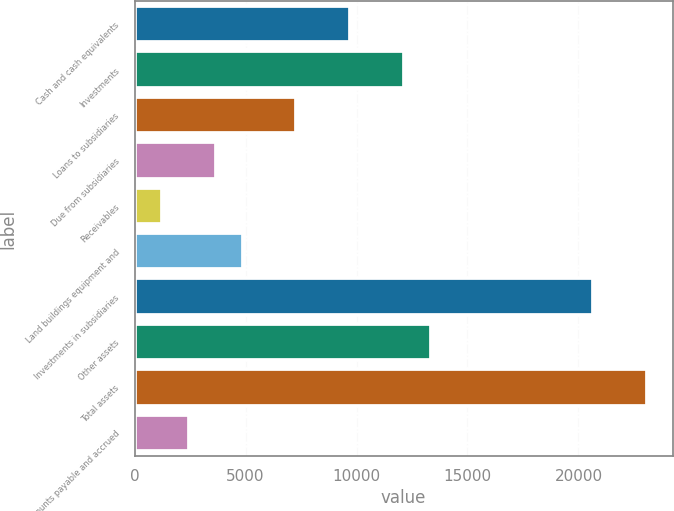<chart> <loc_0><loc_0><loc_500><loc_500><bar_chart><fcel>Cash and cash equivalents<fcel>Investments<fcel>Loans to subsidiaries<fcel>Due from subsidiaries<fcel>Receivables<fcel>Land buildings equipment and<fcel>Investments in subsidiaries<fcel>Other assets<fcel>Total assets<fcel>Accounts payable and accrued<nl><fcel>9725.4<fcel>12156<fcel>7294.8<fcel>3648.9<fcel>1218.3<fcel>4864.2<fcel>20663.1<fcel>13371.3<fcel>23093.7<fcel>2433.6<nl></chart> 